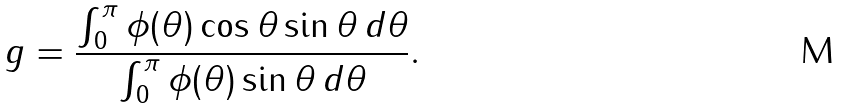<formula> <loc_0><loc_0><loc_500><loc_500>g = \frac { \int _ { 0 } ^ { \pi } \phi ( \theta ) \cos \theta \sin \theta \, d \theta } { \int _ { 0 } ^ { \pi } \phi ( \theta ) \sin \theta \, d \theta } .</formula> 